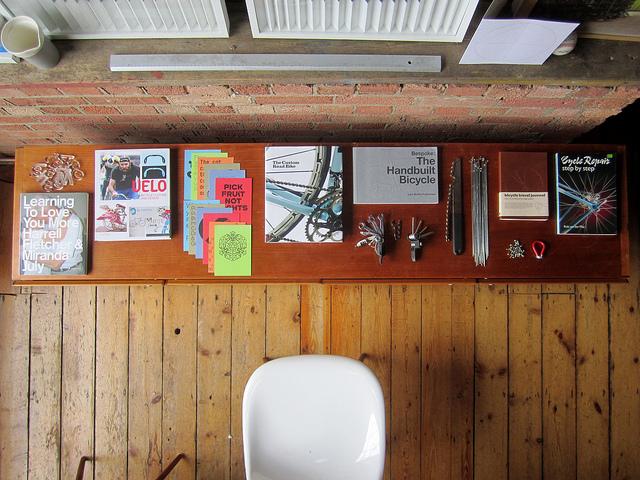Is this a workshop?
Short answer required. Yes. What is this desk owner's primary occupation?
Give a very brief answer. Bicycle repair. What are the books about?
Keep it brief. Bicycles. 